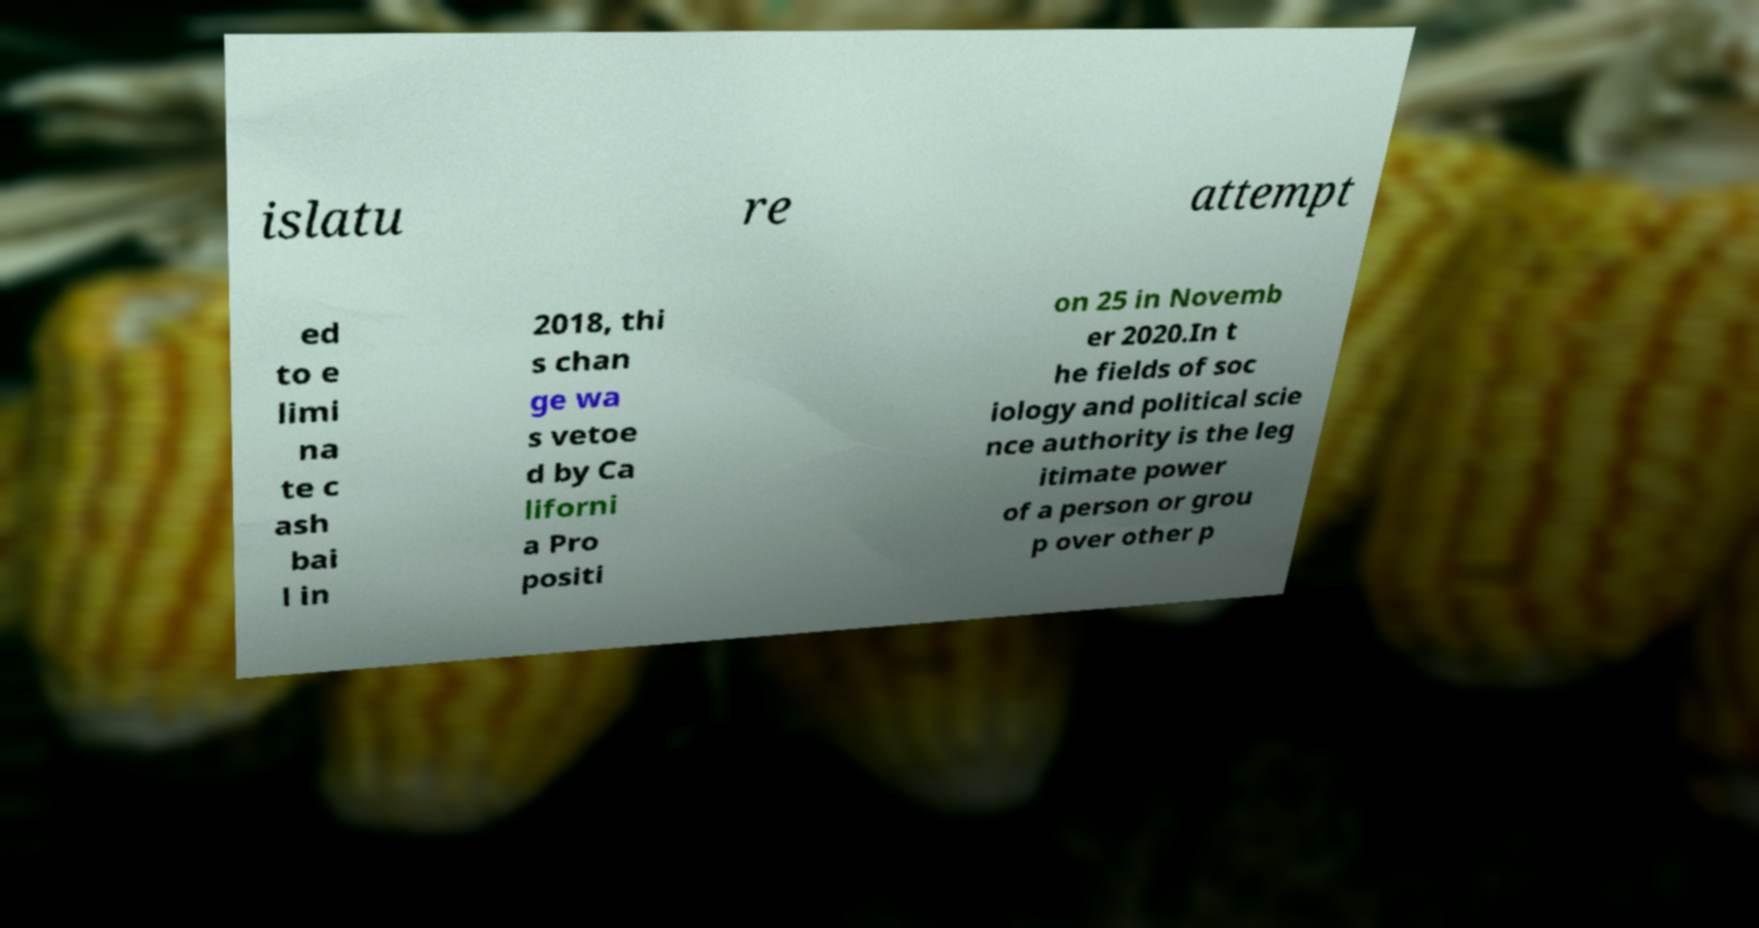Can you accurately transcribe the text from the provided image for me? islatu re attempt ed to e limi na te c ash bai l in 2018, thi s chan ge wa s vetoe d by Ca liforni a Pro positi on 25 in Novemb er 2020.In t he fields of soc iology and political scie nce authority is the leg itimate power of a person or grou p over other p 